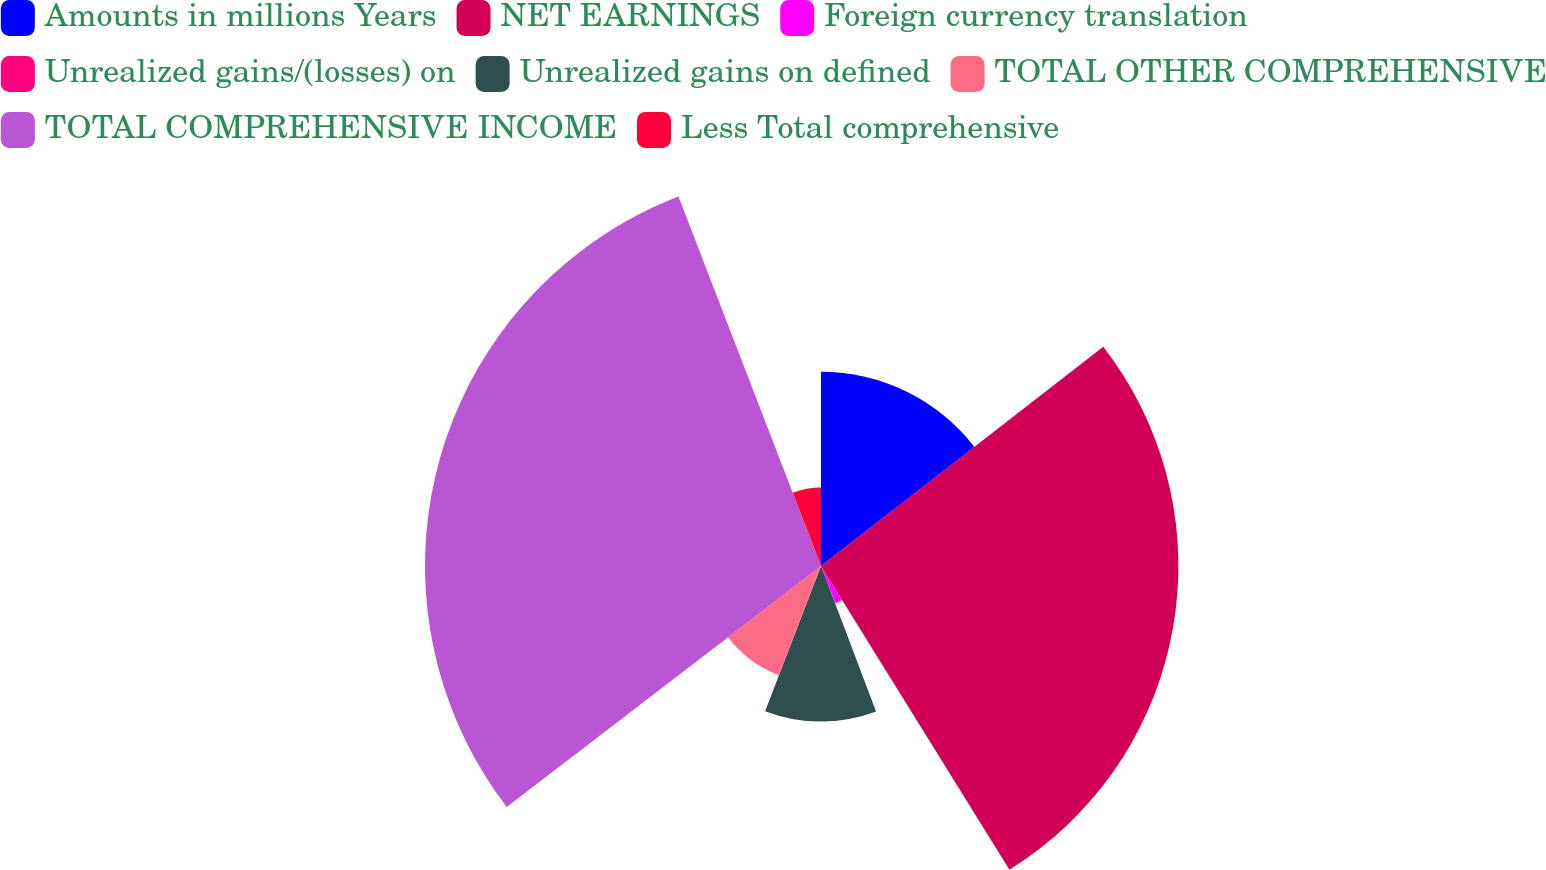<chart> <loc_0><loc_0><loc_500><loc_500><pie_chart><fcel>Amounts in millions Years<fcel>NET EARNINGS<fcel>Foreign currency translation<fcel>Unrealized gains/(losses) on<fcel>Unrealized gains on defined<fcel>TOTAL OTHER COMPREHENSIVE<fcel>TOTAL COMPREHENSIVE INCOME<fcel>Less Total comprehensive<nl><fcel>14.49%<fcel>26.67%<fcel>2.98%<fcel>0.1%<fcel>11.61%<fcel>8.74%<fcel>29.55%<fcel>5.86%<nl></chart> 